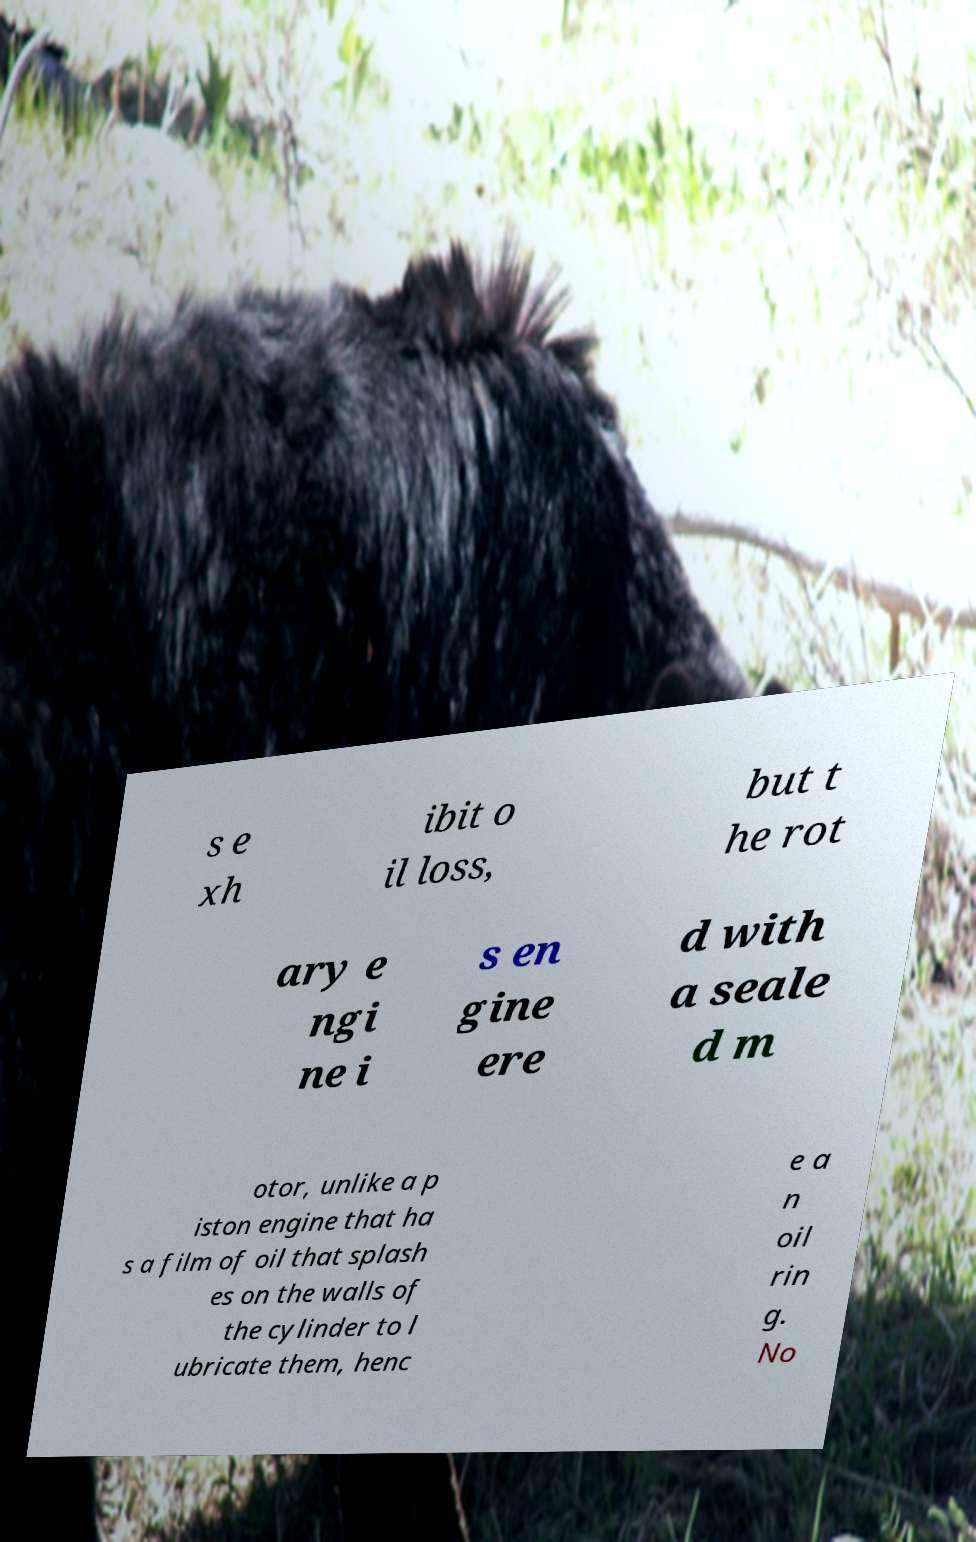Can you read and provide the text displayed in the image?This photo seems to have some interesting text. Can you extract and type it out for me? s e xh ibit o il loss, but t he rot ary e ngi ne i s en gine ere d with a seale d m otor, unlike a p iston engine that ha s a film of oil that splash es on the walls of the cylinder to l ubricate them, henc e a n oil rin g. No 